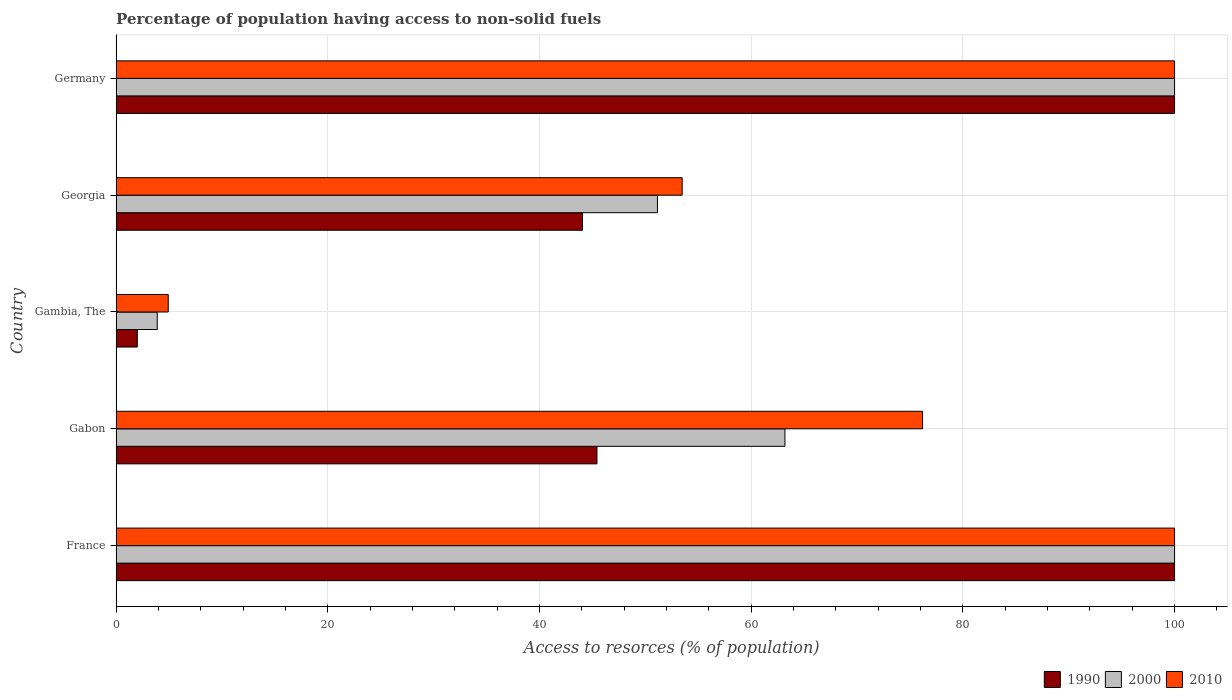How many bars are there on the 3rd tick from the top?
Ensure brevity in your answer.  3. How many bars are there on the 3rd tick from the bottom?
Your answer should be compact. 3. What is the label of the 3rd group of bars from the top?
Keep it short and to the point. Gambia, The. What is the percentage of population having access to non-solid fuels in 1990 in France?
Your answer should be very brief. 100. Across all countries, what is the minimum percentage of population having access to non-solid fuels in 2000?
Offer a terse response. 3.88. In which country was the percentage of population having access to non-solid fuels in 1990 maximum?
Ensure brevity in your answer.  France. In which country was the percentage of population having access to non-solid fuels in 2010 minimum?
Offer a terse response. Gambia, The. What is the total percentage of population having access to non-solid fuels in 2000 in the graph?
Provide a short and direct response. 318.21. What is the difference between the percentage of population having access to non-solid fuels in 2000 in Georgia and that in Germany?
Your answer should be compact. -48.86. What is the difference between the percentage of population having access to non-solid fuels in 2010 in Gambia, The and the percentage of population having access to non-solid fuels in 2000 in Georgia?
Provide a succinct answer. -46.22. What is the average percentage of population having access to non-solid fuels in 2010 per country?
Provide a succinct answer. 66.92. What is the difference between the percentage of population having access to non-solid fuels in 2000 and percentage of population having access to non-solid fuels in 1990 in Georgia?
Make the answer very short. 7.08. In how many countries, is the percentage of population having access to non-solid fuels in 2010 greater than 100 %?
Give a very brief answer. 0. What is the ratio of the percentage of population having access to non-solid fuels in 2000 in France to that in Gambia, The?
Your answer should be compact. 25.75. What is the difference between the highest and the second highest percentage of population having access to non-solid fuels in 2010?
Keep it short and to the point. 0. What is the difference between the highest and the lowest percentage of population having access to non-solid fuels in 2000?
Provide a short and direct response. 96.12. In how many countries, is the percentage of population having access to non-solid fuels in 1990 greater than the average percentage of population having access to non-solid fuels in 1990 taken over all countries?
Keep it short and to the point. 2. What does the 1st bar from the bottom in France represents?
Ensure brevity in your answer.  1990. How many bars are there?
Your response must be concise. 15. Are all the bars in the graph horizontal?
Offer a terse response. Yes. How many countries are there in the graph?
Give a very brief answer. 5. What is the difference between two consecutive major ticks on the X-axis?
Ensure brevity in your answer.  20. Does the graph contain any zero values?
Provide a short and direct response. No. What is the title of the graph?
Provide a succinct answer. Percentage of population having access to non-solid fuels. What is the label or title of the X-axis?
Give a very brief answer. Access to resorces (% of population). What is the label or title of the Y-axis?
Make the answer very short. Country. What is the Access to resorces (% of population) of 1990 in Gabon?
Your answer should be compact. 45.43. What is the Access to resorces (% of population) of 2000 in Gabon?
Your answer should be very brief. 63.19. What is the Access to resorces (% of population) in 2010 in Gabon?
Give a very brief answer. 76.19. What is the Access to resorces (% of population) in 1990 in Gambia, The?
Give a very brief answer. 2. What is the Access to resorces (% of population) of 2000 in Gambia, The?
Give a very brief answer. 3.88. What is the Access to resorces (% of population) of 2010 in Gambia, The?
Offer a very short reply. 4.92. What is the Access to resorces (% of population) in 1990 in Georgia?
Ensure brevity in your answer.  44.06. What is the Access to resorces (% of population) in 2000 in Georgia?
Your answer should be compact. 51.14. What is the Access to resorces (% of population) in 2010 in Georgia?
Ensure brevity in your answer.  53.48. Across all countries, what is the minimum Access to resorces (% of population) in 1990?
Give a very brief answer. 2. Across all countries, what is the minimum Access to resorces (% of population) of 2000?
Your response must be concise. 3.88. Across all countries, what is the minimum Access to resorces (% of population) in 2010?
Offer a very short reply. 4.92. What is the total Access to resorces (% of population) in 1990 in the graph?
Keep it short and to the point. 291.49. What is the total Access to resorces (% of population) in 2000 in the graph?
Your answer should be compact. 318.21. What is the total Access to resorces (% of population) of 2010 in the graph?
Your answer should be compact. 334.59. What is the difference between the Access to resorces (% of population) in 1990 in France and that in Gabon?
Offer a very short reply. 54.57. What is the difference between the Access to resorces (% of population) of 2000 in France and that in Gabon?
Your answer should be compact. 36.81. What is the difference between the Access to resorces (% of population) in 2010 in France and that in Gabon?
Your answer should be very brief. 23.81. What is the difference between the Access to resorces (% of population) in 2000 in France and that in Gambia, The?
Offer a terse response. 96.12. What is the difference between the Access to resorces (% of population) of 2010 in France and that in Gambia, The?
Give a very brief answer. 95.08. What is the difference between the Access to resorces (% of population) of 1990 in France and that in Georgia?
Give a very brief answer. 55.94. What is the difference between the Access to resorces (% of population) of 2000 in France and that in Georgia?
Provide a succinct answer. 48.86. What is the difference between the Access to resorces (% of population) in 2010 in France and that in Georgia?
Offer a terse response. 46.52. What is the difference between the Access to resorces (% of population) in 2000 in France and that in Germany?
Ensure brevity in your answer.  0. What is the difference between the Access to resorces (% of population) in 2010 in France and that in Germany?
Give a very brief answer. 0. What is the difference between the Access to resorces (% of population) of 1990 in Gabon and that in Gambia, The?
Offer a very short reply. 43.43. What is the difference between the Access to resorces (% of population) of 2000 in Gabon and that in Gambia, The?
Ensure brevity in your answer.  59.3. What is the difference between the Access to resorces (% of population) in 2010 in Gabon and that in Gambia, The?
Provide a succinct answer. 71.27. What is the difference between the Access to resorces (% of population) of 1990 in Gabon and that in Georgia?
Ensure brevity in your answer.  1.37. What is the difference between the Access to resorces (% of population) of 2000 in Gabon and that in Georgia?
Provide a short and direct response. 12.04. What is the difference between the Access to resorces (% of population) of 2010 in Gabon and that in Georgia?
Provide a short and direct response. 22.72. What is the difference between the Access to resorces (% of population) of 1990 in Gabon and that in Germany?
Provide a short and direct response. -54.57. What is the difference between the Access to resorces (% of population) in 2000 in Gabon and that in Germany?
Offer a terse response. -36.81. What is the difference between the Access to resorces (% of population) of 2010 in Gabon and that in Germany?
Offer a very short reply. -23.81. What is the difference between the Access to resorces (% of population) in 1990 in Gambia, The and that in Georgia?
Make the answer very short. -42.06. What is the difference between the Access to resorces (% of population) in 2000 in Gambia, The and that in Georgia?
Ensure brevity in your answer.  -47.26. What is the difference between the Access to resorces (% of population) of 2010 in Gambia, The and that in Georgia?
Give a very brief answer. -48.56. What is the difference between the Access to resorces (% of population) in 1990 in Gambia, The and that in Germany?
Make the answer very short. -98. What is the difference between the Access to resorces (% of population) of 2000 in Gambia, The and that in Germany?
Your answer should be very brief. -96.12. What is the difference between the Access to resorces (% of population) of 2010 in Gambia, The and that in Germany?
Ensure brevity in your answer.  -95.08. What is the difference between the Access to resorces (% of population) of 1990 in Georgia and that in Germany?
Give a very brief answer. -55.94. What is the difference between the Access to resorces (% of population) in 2000 in Georgia and that in Germany?
Your answer should be compact. -48.86. What is the difference between the Access to resorces (% of population) of 2010 in Georgia and that in Germany?
Offer a very short reply. -46.52. What is the difference between the Access to resorces (% of population) of 1990 in France and the Access to resorces (% of population) of 2000 in Gabon?
Your response must be concise. 36.81. What is the difference between the Access to resorces (% of population) in 1990 in France and the Access to resorces (% of population) in 2010 in Gabon?
Your answer should be compact. 23.81. What is the difference between the Access to resorces (% of population) of 2000 in France and the Access to resorces (% of population) of 2010 in Gabon?
Provide a succinct answer. 23.81. What is the difference between the Access to resorces (% of population) of 1990 in France and the Access to resorces (% of population) of 2000 in Gambia, The?
Your answer should be very brief. 96.12. What is the difference between the Access to resorces (% of population) of 1990 in France and the Access to resorces (% of population) of 2010 in Gambia, The?
Keep it short and to the point. 95.08. What is the difference between the Access to resorces (% of population) in 2000 in France and the Access to resorces (% of population) in 2010 in Gambia, The?
Provide a short and direct response. 95.08. What is the difference between the Access to resorces (% of population) in 1990 in France and the Access to resorces (% of population) in 2000 in Georgia?
Your response must be concise. 48.86. What is the difference between the Access to resorces (% of population) in 1990 in France and the Access to resorces (% of population) in 2010 in Georgia?
Make the answer very short. 46.52. What is the difference between the Access to resorces (% of population) of 2000 in France and the Access to resorces (% of population) of 2010 in Georgia?
Your answer should be compact. 46.52. What is the difference between the Access to resorces (% of population) in 1990 in France and the Access to resorces (% of population) in 2000 in Germany?
Give a very brief answer. 0. What is the difference between the Access to resorces (% of population) in 1990 in France and the Access to resorces (% of population) in 2010 in Germany?
Your response must be concise. 0. What is the difference between the Access to resorces (% of population) of 1990 in Gabon and the Access to resorces (% of population) of 2000 in Gambia, The?
Your answer should be very brief. 41.55. What is the difference between the Access to resorces (% of population) in 1990 in Gabon and the Access to resorces (% of population) in 2010 in Gambia, The?
Ensure brevity in your answer.  40.51. What is the difference between the Access to resorces (% of population) in 2000 in Gabon and the Access to resorces (% of population) in 2010 in Gambia, The?
Offer a terse response. 58.26. What is the difference between the Access to resorces (% of population) in 1990 in Gabon and the Access to resorces (% of population) in 2000 in Georgia?
Ensure brevity in your answer.  -5.71. What is the difference between the Access to resorces (% of population) in 1990 in Gabon and the Access to resorces (% of population) in 2010 in Georgia?
Offer a very short reply. -8.05. What is the difference between the Access to resorces (% of population) in 2000 in Gabon and the Access to resorces (% of population) in 2010 in Georgia?
Offer a terse response. 9.71. What is the difference between the Access to resorces (% of population) in 1990 in Gabon and the Access to resorces (% of population) in 2000 in Germany?
Your answer should be compact. -54.57. What is the difference between the Access to resorces (% of population) of 1990 in Gabon and the Access to resorces (% of population) of 2010 in Germany?
Offer a terse response. -54.57. What is the difference between the Access to resorces (% of population) in 2000 in Gabon and the Access to resorces (% of population) in 2010 in Germany?
Give a very brief answer. -36.81. What is the difference between the Access to resorces (% of population) in 1990 in Gambia, The and the Access to resorces (% of population) in 2000 in Georgia?
Keep it short and to the point. -49.14. What is the difference between the Access to resorces (% of population) of 1990 in Gambia, The and the Access to resorces (% of population) of 2010 in Georgia?
Offer a terse response. -51.48. What is the difference between the Access to resorces (% of population) in 2000 in Gambia, The and the Access to resorces (% of population) in 2010 in Georgia?
Your answer should be compact. -49.59. What is the difference between the Access to resorces (% of population) in 1990 in Gambia, The and the Access to resorces (% of population) in 2000 in Germany?
Ensure brevity in your answer.  -98. What is the difference between the Access to resorces (% of population) of 1990 in Gambia, The and the Access to resorces (% of population) of 2010 in Germany?
Give a very brief answer. -98. What is the difference between the Access to resorces (% of population) in 2000 in Gambia, The and the Access to resorces (% of population) in 2010 in Germany?
Provide a succinct answer. -96.12. What is the difference between the Access to resorces (% of population) of 1990 in Georgia and the Access to resorces (% of population) of 2000 in Germany?
Offer a very short reply. -55.94. What is the difference between the Access to resorces (% of population) of 1990 in Georgia and the Access to resorces (% of population) of 2010 in Germany?
Your answer should be compact. -55.94. What is the difference between the Access to resorces (% of population) of 2000 in Georgia and the Access to resorces (% of population) of 2010 in Germany?
Make the answer very short. -48.86. What is the average Access to resorces (% of population) in 1990 per country?
Offer a very short reply. 58.3. What is the average Access to resorces (% of population) of 2000 per country?
Offer a very short reply. 63.64. What is the average Access to resorces (% of population) of 2010 per country?
Your response must be concise. 66.92. What is the difference between the Access to resorces (% of population) in 1990 and Access to resorces (% of population) in 2000 in France?
Keep it short and to the point. 0. What is the difference between the Access to resorces (% of population) of 1990 and Access to resorces (% of population) of 2010 in France?
Provide a short and direct response. 0. What is the difference between the Access to resorces (% of population) in 1990 and Access to resorces (% of population) in 2000 in Gabon?
Provide a short and direct response. -17.76. What is the difference between the Access to resorces (% of population) in 1990 and Access to resorces (% of population) in 2010 in Gabon?
Provide a short and direct response. -30.76. What is the difference between the Access to resorces (% of population) in 2000 and Access to resorces (% of population) in 2010 in Gabon?
Offer a very short reply. -13.01. What is the difference between the Access to resorces (% of population) in 1990 and Access to resorces (% of population) in 2000 in Gambia, The?
Give a very brief answer. -1.88. What is the difference between the Access to resorces (% of population) of 1990 and Access to resorces (% of population) of 2010 in Gambia, The?
Offer a very short reply. -2.92. What is the difference between the Access to resorces (% of population) in 2000 and Access to resorces (% of population) in 2010 in Gambia, The?
Provide a succinct answer. -1.04. What is the difference between the Access to resorces (% of population) in 1990 and Access to resorces (% of population) in 2000 in Georgia?
Your response must be concise. -7.08. What is the difference between the Access to resorces (% of population) in 1990 and Access to resorces (% of population) in 2010 in Georgia?
Give a very brief answer. -9.42. What is the difference between the Access to resorces (% of population) in 2000 and Access to resorces (% of population) in 2010 in Georgia?
Make the answer very short. -2.33. What is the difference between the Access to resorces (% of population) in 1990 and Access to resorces (% of population) in 2000 in Germany?
Provide a short and direct response. 0. What is the difference between the Access to resorces (% of population) in 2000 and Access to resorces (% of population) in 2010 in Germany?
Ensure brevity in your answer.  0. What is the ratio of the Access to resorces (% of population) in 1990 in France to that in Gabon?
Your answer should be very brief. 2.2. What is the ratio of the Access to resorces (% of population) of 2000 in France to that in Gabon?
Provide a succinct answer. 1.58. What is the ratio of the Access to resorces (% of population) in 2010 in France to that in Gabon?
Your answer should be compact. 1.31. What is the ratio of the Access to resorces (% of population) of 1990 in France to that in Gambia, The?
Keep it short and to the point. 50. What is the ratio of the Access to resorces (% of population) of 2000 in France to that in Gambia, The?
Your response must be concise. 25.75. What is the ratio of the Access to resorces (% of population) in 2010 in France to that in Gambia, The?
Keep it short and to the point. 20.32. What is the ratio of the Access to resorces (% of population) of 1990 in France to that in Georgia?
Give a very brief answer. 2.27. What is the ratio of the Access to resorces (% of population) in 2000 in France to that in Georgia?
Give a very brief answer. 1.96. What is the ratio of the Access to resorces (% of population) in 2010 in France to that in Georgia?
Provide a short and direct response. 1.87. What is the ratio of the Access to resorces (% of population) in 1990 in France to that in Germany?
Offer a terse response. 1. What is the ratio of the Access to resorces (% of population) of 2000 in France to that in Germany?
Provide a succinct answer. 1. What is the ratio of the Access to resorces (% of population) in 1990 in Gabon to that in Gambia, The?
Make the answer very short. 22.71. What is the ratio of the Access to resorces (% of population) in 2000 in Gabon to that in Gambia, The?
Your response must be concise. 16.27. What is the ratio of the Access to resorces (% of population) of 2010 in Gabon to that in Gambia, The?
Provide a short and direct response. 15.48. What is the ratio of the Access to resorces (% of population) of 1990 in Gabon to that in Georgia?
Your response must be concise. 1.03. What is the ratio of the Access to resorces (% of population) of 2000 in Gabon to that in Georgia?
Offer a terse response. 1.24. What is the ratio of the Access to resorces (% of population) of 2010 in Gabon to that in Georgia?
Provide a succinct answer. 1.42. What is the ratio of the Access to resorces (% of population) of 1990 in Gabon to that in Germany?
Offer a terse response. 0.45. What is the ratio of the Access to resorces (% of population) in 2000 in Gabon to that in Germany?
Ensure brevity in your answer.  0.63. What is the ratio of the Access to resorces (% of population) of 2010 in Gabon to that in Germany?
Provide a succinct answer. 0.76. What is the ratio of the Access to resorces (% of population) in 1990 in Gambia, The to that in Georgia?
Your response must be concise. 0.05. What is the ratio of the Access to resorces (% of population) in 2000 in Gambia, The to that in Georgia?
Offer a very short reply. 0.08. What is the ratio of the Access to resorces (% of population) of 2010 in Gambia, The to that in Georgia?
Provide a short and direct response. 0.09. What is the ratio of the Access to resorces (% of population) in 1990 in Gambia, The to that in Germany?
Provide a short and direct response. 0.02. What is the ratio of the Access to resorces (% of population) in 2000 in Gambia, The to that in Germany?
Offer a very short reply. 0.04. What is the ratio of the Access to resorces (% of population) of 2010 in Gambia, The to that in Germany?
Your answer should be very brief. 0.05. What is the ratio of the Access to resorces (% of population) of 1990 in Georgia to that in Germany?
Your answer should be compact. 0.44. What is the ratio of the Access to resorces (% of population) of 2000 in Georgia to that in Germany?
Your response must be concise. 0.51. What is the ratio of the Access to resorces (% of population) in 2010 in Georgia to that in Germany?
Keep it short and to the point. 0.53. What is the difference between the highest and the second highest Access to resorces (% of population) in 1990?
Provide a short and direct response. 0. What is the difference between the highest and the second highest Access to resorces (% of population) in 2000?
Your answer should be compact. 0. What is the difference between the highest and the second highest Access to resorces (% of population) in 2010?
Make the answer very short. 0. What is the difference between the highest and the lowest Access to resorces (% of population) in 2000?
Give a very brief answer. 96.12. What is the difference between the highest and the lowest Access to resorces (% of population) in 2010?
Your answer should be very brief. 95.08. 